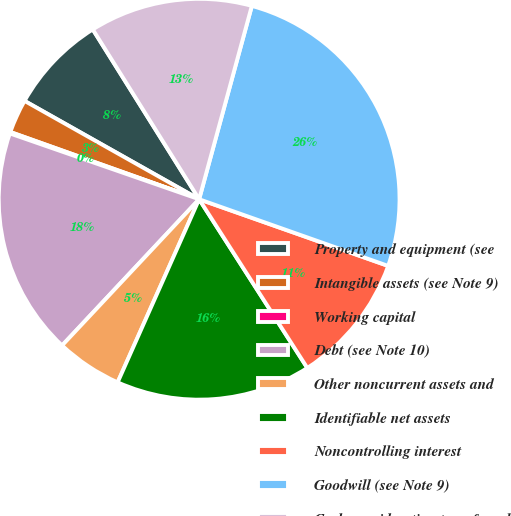Convert chart to OTSL. <chart><loc_0><loc_0><loc_500><loc_500><pie_chart><fcel>Property and equipment (see<fcel>Intangible assets (see Note 9)<fcel>Working capital<fcel>Debt (see Note 10)<fcel>Other noncurrent assets and<fcel>Identifiable net assets<fcel>Noncontrolling interest<fcel>Goodwill (see Note 9)<fcel>Cash consideration transferred<nl><fcel>7.93%<fcel>2.72%<fcel>0.12%<fcel>18.34%<fcel>5.32%<fcel>15.74%<fcel>10.53%<fcel>26.16%<fcel>13.14%<nl></chart> 